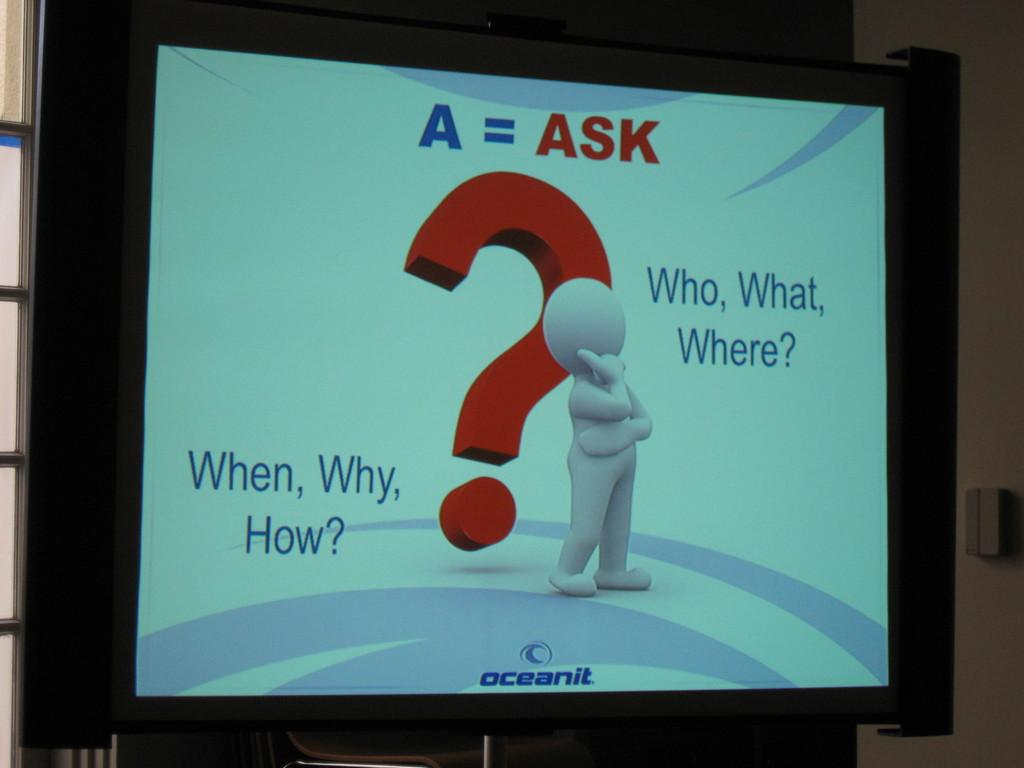<image>
Describe the image concisely. A monitor screen shows a number of questions relating to the company OceanIT. 